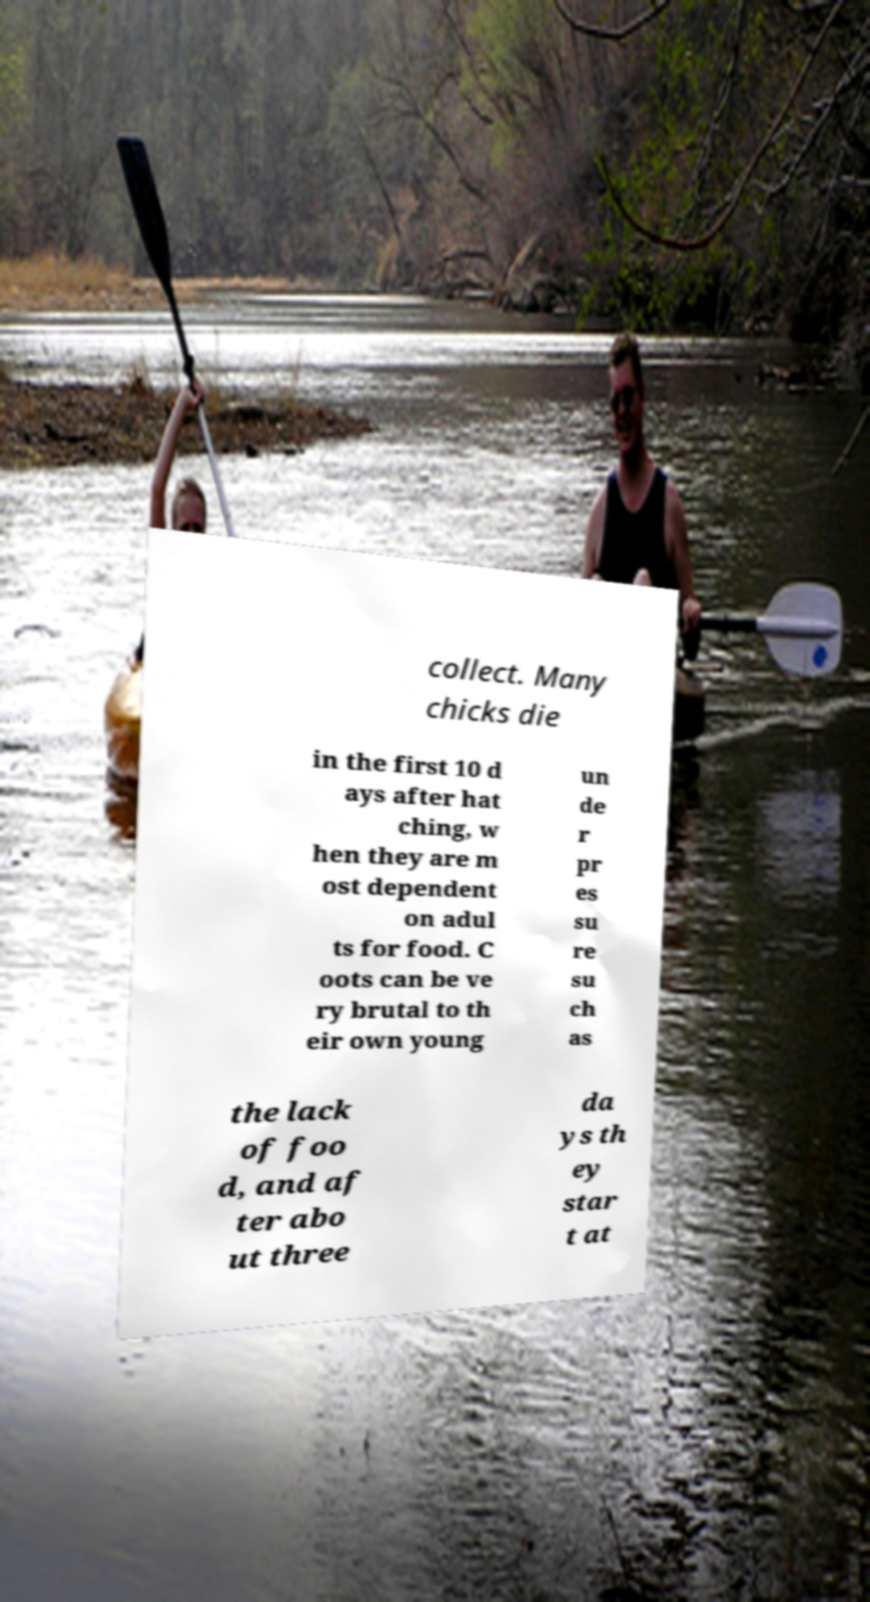Please identify and transcribe the text found in this image. collect. Many chicks die in the first 10 d ays after hat ching, w hen they are m ost dependent on adul ts for food. C oots can be ve ry brutal to th eir own young un de r pr es su re su ch as the lack of foo d, and af ter abo ut three da ys th ey star t at 